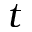Convert formula to latex. <formula><loc_0><loc_0><loc_500><loc_500>t</formula> 